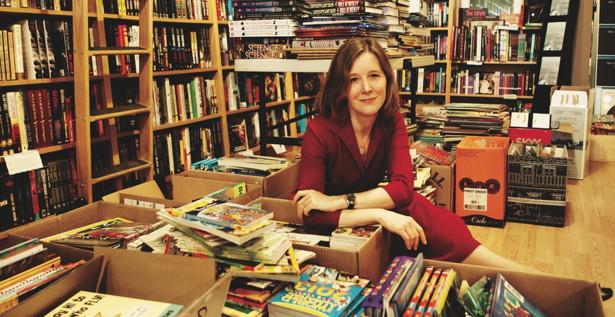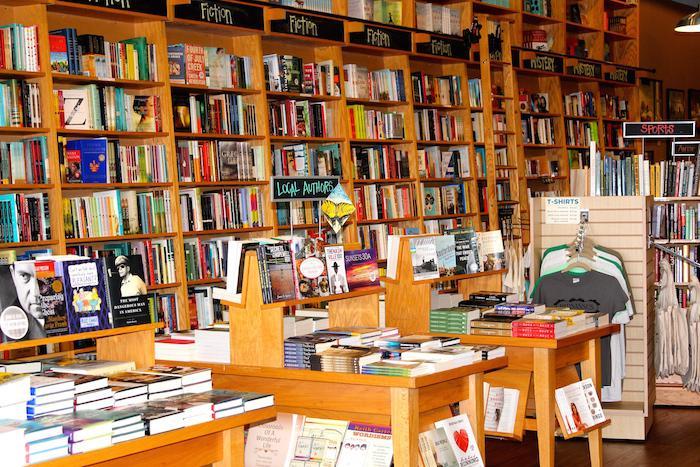The first image is the image on the left, the second image is the image on the right. Evaluate the accuracy of this statement regarding the images: "A woman in a red blouse is sitting at a table of books in one of the images.". Is it true? Answer yes or no. Yes. The first image is the image on the left, the second image is the image on the right. Analyze the images presented: Is the assertion "One image shows a red-headed woman in a reddish dress sitting in front of open boxes of books." valid? Answer yes or no. Yes. 